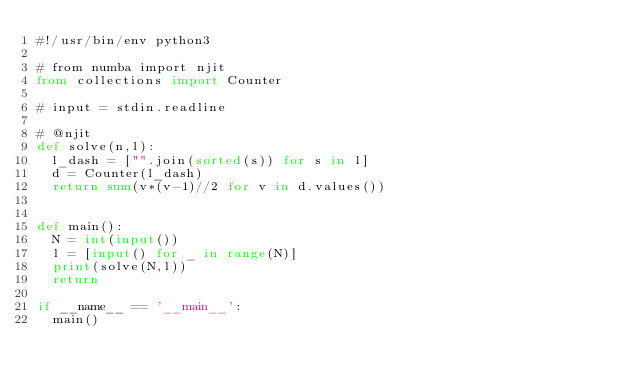<code> <loc_0><loc_0><loc_500><loc_500><_Python_>#!/usr/bin/env python3

# from numba import njit
from collections import Counter

# input = stdin.readline

# @njit
def solve(n,l):
  l_dash = ["".join(sorted(s)) for s in l]
  d = Counter(l_dash)
  return sum(v*(v-1)//2 for v in d.values())


def main():
  N = int(input())
  l = [input() for _ in range(N)]
  print(solve(N,l))
  return

if __name__ == '__main__':
  main()
</code> 